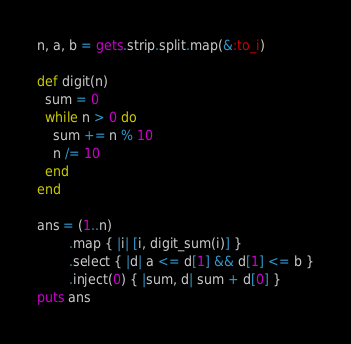<code> <loc_0><loc_0><loc_500><loc_500><_Ruby_>n, a, b = gets.strip.split.map(&:to_i)

def digit(n)
  sum = 0
  while n > 0 do
    sum += n % 10
    n /= 10
  end
end

ans = (1..n)
        .map { |i| [i, digit_sum(i)] }
        .select { |d| a <= d[1] && d[1] <= b }
        .inject(0) { |sum, d| sum + d[0] }
puts ans 
</code> 